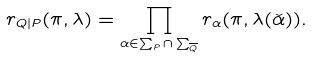Convert formula to latex. <formula><loc_0><loc_0><loc_500><loc_500>r _ { Q | P } ( \pi , \lambda ) = \prod _ { \alpha \in \sum _ { P } \cap \sum _ { \overline { Q } } } r _ { \alpha } ( \pi , \lambda ( \check { \alpha } ) ) .</formula> 